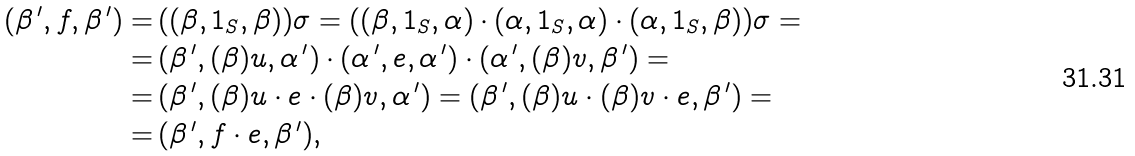<formula> <loc_0><loc_0><loc_500><loc_500>( \beta ^ { \, \prime } , f , \beta ^ { \, \prime } ) = & \, ( ( \beta , 1 _ { S } , \beta ) ) \sigma = ( ( \beta , 1 _ { S } , \alpha ) \cdot ( \alpha , 1 _ { S } , \alpha ) \cdot ( \alpha , 1 _ { S } , \beta ) ) \sigma = \\ = & \, ( \beta ^ { \, \prime } , ( \beta ) u , \alpha ^ { \, \prime } ) \cdot ( \alpha ^ { \, \prime } , e , \alpha ^ { \, \prime } ) \cdot ( \alpha ^ { \, \prime } , ( \beta ) v , \beta ^ { \, \prime } ) = \\ = & \, ( \beta ^ { \, \prime } , ( \beta ) u \cdot e \cdot ( \beta ) v , \alpha ^ { \, \prime } ) = ( \beta ^ { \, \prime } , ( \beta ) u \cdot ( \beta ) v \cdot e , \beta ^ { \, \prime } ) = \\ = & \, ( \beta ^ { \, \prime } , f \cdot e , \beta ^ { \, \prime } ) ,</formula> 